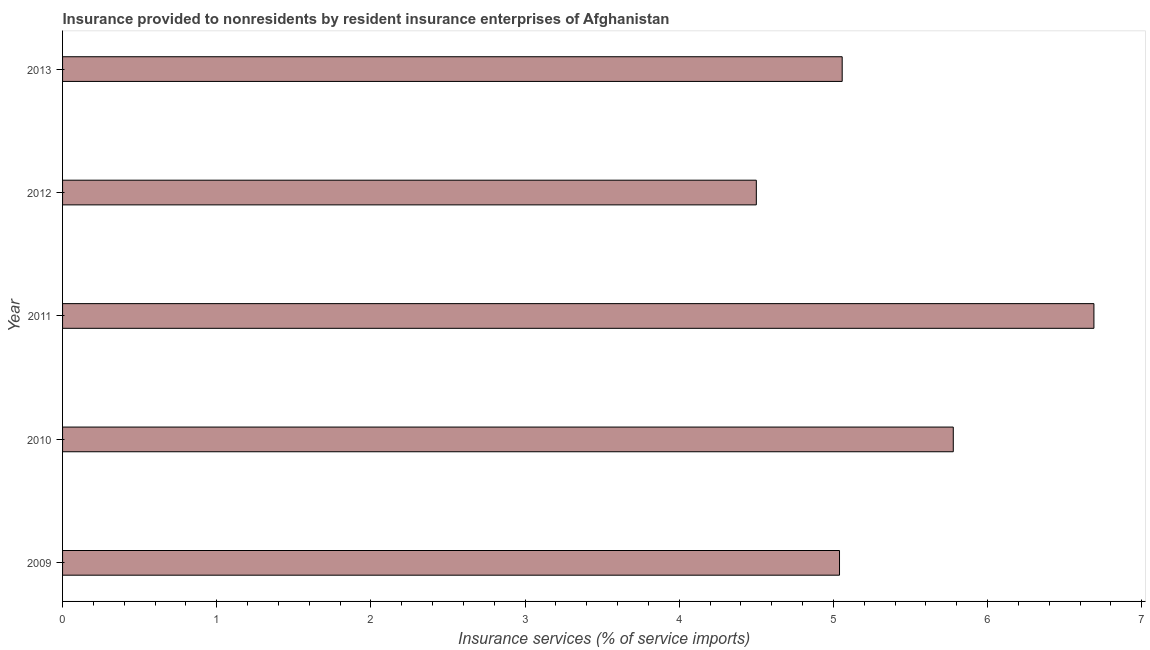Does the graph contain grids?
Your response must be concise. No. What is the title of the graph?
Make the answer very short. Insurance provided to nonresidents by resident insurance enterprises of Afghanistan. What is the label or title of the X-axis?
Your answer should be very brief. Insurance services (% of service imports). What is the insurance and financial services in 2012?
Offer a terse response. 4.5. Across all years, what is the maximum insurance and financial services?
Your response must be concise. 6.69. Across all years, what is the minimum insurance and financial services?
Make the answer very short. 4.5. In which year was the insurance and financial services maximum?
Provide a succinct answer. 2011. What is the sum of the insurance and financial services?
Your answer should be compact. 27.06. What is the difference between the insurance and financial services in 2009 and 2013?
Ensure brevity in your answer.  -0.02. What is the average insurance and financial services per year?
Give a very brief answer. 5.41. What is the median insurance and financial services?
Your answer should be very brief. 5.06. Do a majority of the years between 2011 and 2013 (inclusive) have insurance and financial services greater than 2.8 %?
Your answer should be compact. Yes. What is the ratio of the insurance and financial services in 2009 to that in 2011?
Your response must be concise. 0.75. Is the insurance and financial services in 2009 less than that in 2010?
Give a very brief answer. Yes. What is the difference between the highest and the second highest insurance and financial services?
Provide a short and direct response. 0.91. What is the difference between the highest and the lowest insurance and financial services?
Give a very brief answer. 2.19. In how many years, is the insurance and financial services greater than the average insurance and financial services taken over all years?
Your response must be concise. 2. How many bars are there?
Offer a terse response. 5. Are all the bars in the graph horizontal?
Make the answer very short. Yes. How many years are there in the graph?
Your response must be concise. 5. What is the difference between two consecutive major ticks on the X-axis?
Offer a terse response. 1. What is the Insurance services (% of service imports) in 2009?
Provide a short and direct response. 5.04. What is the Insurance services (% of service imports) of 2010?
Offer a very short reply. 5.78. What is the Insurance services (% of service imports) in 2011?
Give a very brief answer. 6.69. What is the Insurance services (% of service imports) in 2012?
Offer a terse response. 4.5. What is the Insurance services (% of service imports) in 2013?
Offer a very short reply. 5.06. What is the difference between the Insurance services (% of service imports) in 2009 and 2010?
Give a very brief answer. -0.74. What is the difference between the Insurance services (% of service imports) in 2009 and 2011?
Your answer should be compact. -1.65. What is the difference between the Insurance services (% of service imports) in 2009 and 2012?
Offer a very short reply. 0.54. What is the difference between the Insurance services (% of service imports) in 2009 and 2013?
Keep it short and to the point. -0.02. What is the difference between the Insurance services (% of service imports) in 2010 and 2011?
Provide a short and direct response. -0.91. What is the difference between the Insurance services (% of service imports) in 2010 and 2012?
Your answer should be compact. 1.28. What is the difference between the Insurance services (% of service imports) in 2010 and 2013?
Offer a very short reply. 0.72. What is the difference between the Insurance services (% of service imports) in 2011 and 2012?
Offer a very short reply. 2.19. What is the difference between the Insurance services (% of service imports) in 2011 and 2013?
Give a very brief answer. 1.63. What is the difference between the Insurance services (% of service imports) in 2012 and 2013?
Provide a short and direct response. -0.56. What is the ratio of the Insurance services (% of service imports) in 2009 to that in 2010?
Your answer should be compact. 0.87. What is the ratio of the Insurance services (% of service imports) in 2009 to that in 2011?
Your answer should be compact. 0.75. What is the ratio of the Insurance services (% of service imports) in 2009 to that in 2012?
Your response must be concise. 1.12. What is the ratio of the Insurance services (% of service imports) in 2010 to that in 2011?
Provide a succinct answer. 0.86. What is the ratio of the Insurance services (% of service imports) in 2010 to that in 2012?
Ensure brevity in your answer.  1.28. What is the ratio of the Insurance services (% of service imports) in 2010 to that in 2013?
Provide a succinct answer. 1.14. What is the ratio of the Insurance services (% of service imports) in 2011 to that in 2012?
Your response must be concise. 1.49. What is the ratio of the Insurance services (% of service imports) in 2011 to that in 2013?
Give a very brief answer. 1.32. What is the ratio of the Insurance services (% of service imports) in 2012 to that in 2013?
Your response must be concise. 0.89. 